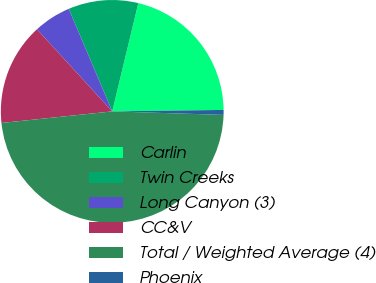Convert chart to OTSL. <chart><loc_0><loc_0><loc_500><loc_500><pie_chart><fcel>Carlin<fcel>Twin Creeks<fcel>Long Canyon (3)<fcel>CC&V<fcel>Total / Weighted Average (4)<fcel>Phoenix<nl><fcel>21.03%<fcel>10.14%<fcel>5.43%<fcel>14.85%<fcel>47.84%<fcel>0.71%<nl></chart> 